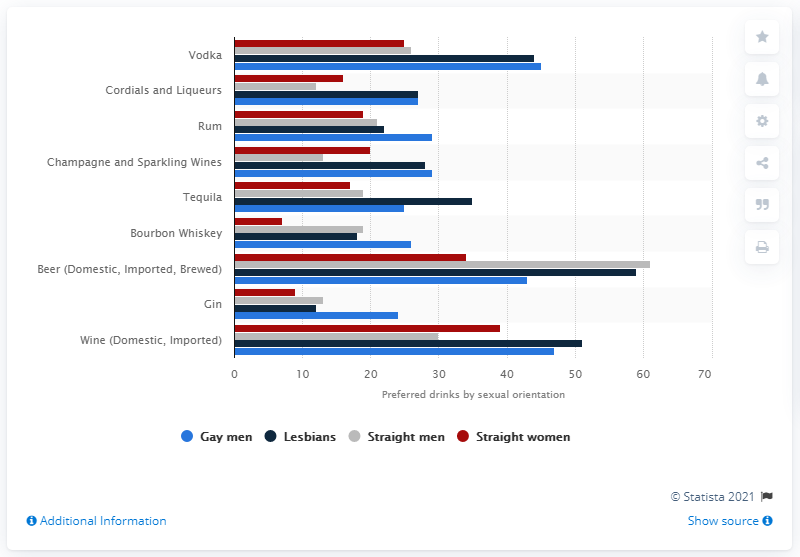What percentage of gay and lesbian respondents said they drink Vodka? Approximately 45% of gay men and about 40% of lesbians reported that they drink vodka, according to the bar chart in the image. It's interesting to note the difference in preferences, suggesting vodka is a popular choice among both demographics in this survey. 